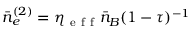Convert formula to latex. <formula><loc_0><loc_0><loc_500><loc_500>\bar { n } _ { e } ^ { ( 2 ) } = \eta _ { e f f } \bar { n } _ { B } ( 1 - \tau ) ^ { - 1 }</formula> 